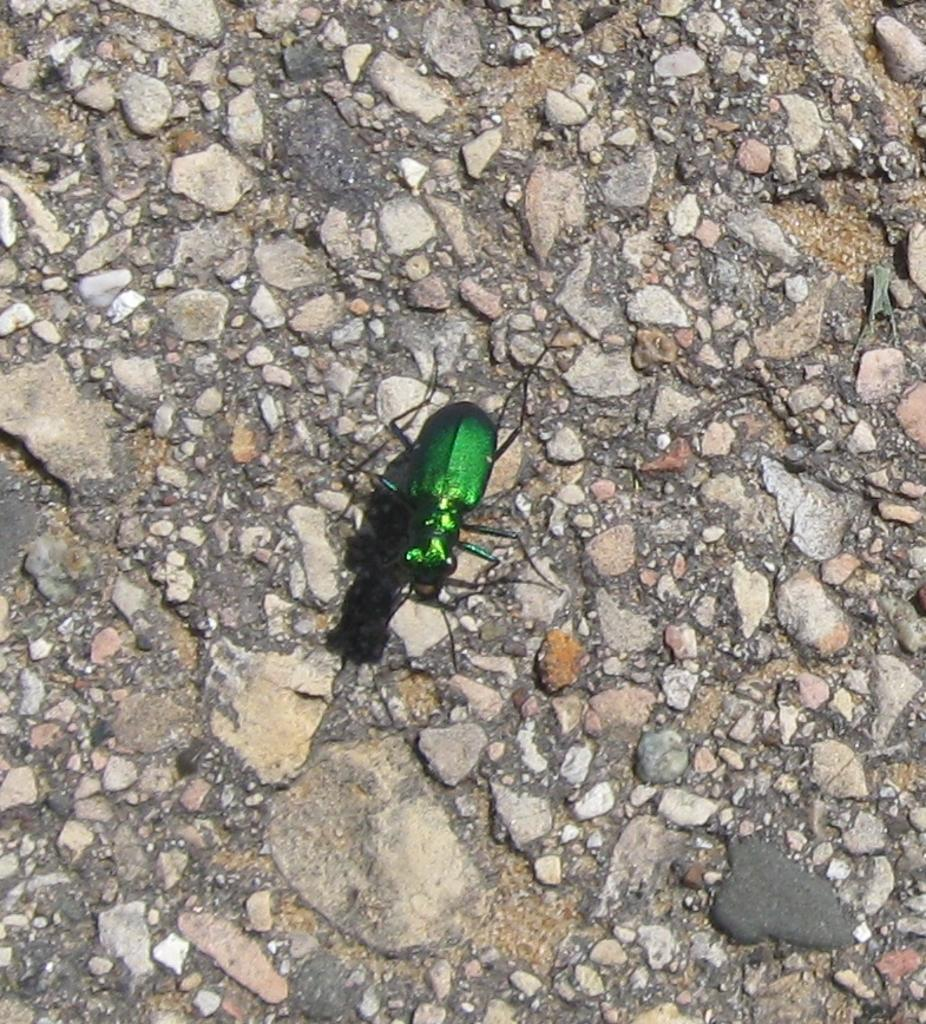What is located on the ground in the image? There is an insect on the ground in the image. What else can be seen on the ground in the image? Small stones are present in the ground in the image. What type of cork can be seen in the image? There is no cork present in the image. What form does the train take in the image? There is no train present in the image. 